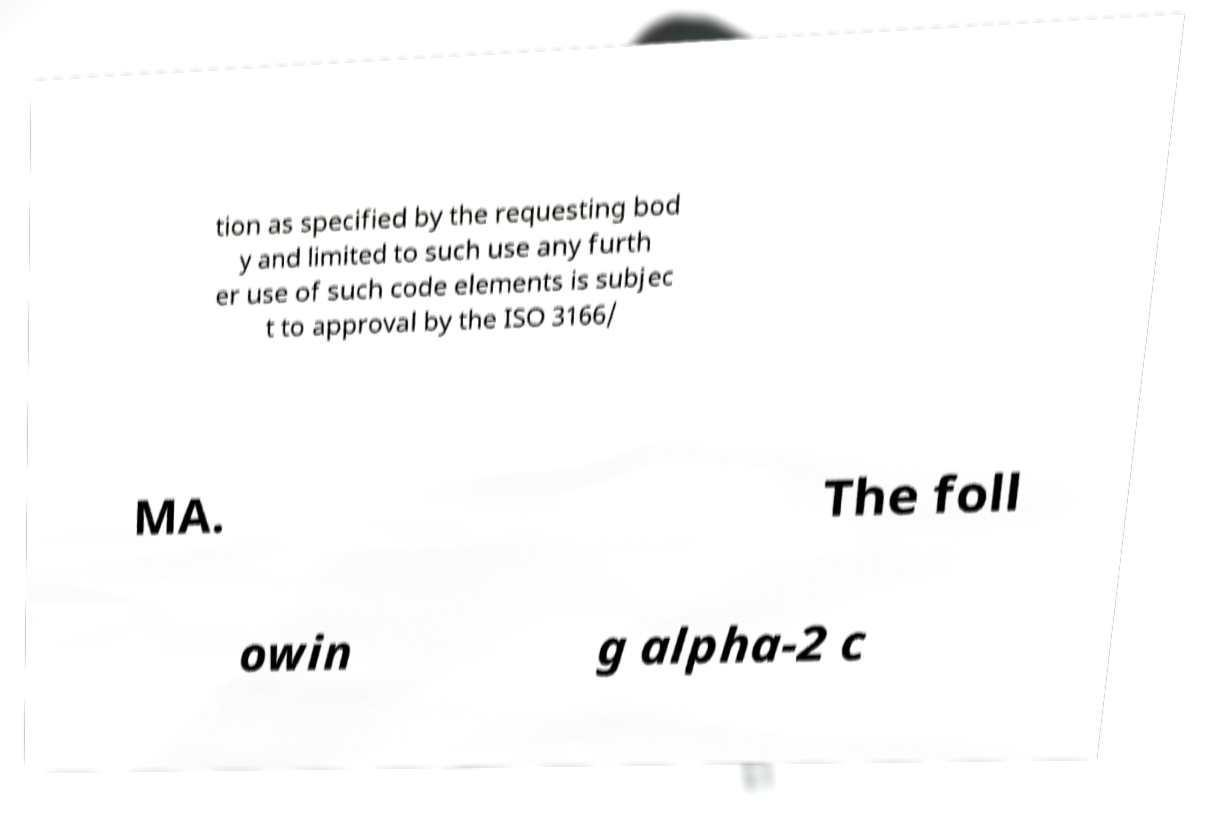Could you assist in decoding the text presented in this image and type it out clearly? tion as specified by the requesting bod y and limited to such use any furth er use of such code elements is subjec t to approval by the ISO 3166/ MA. The foll owin g alpha-2 c 